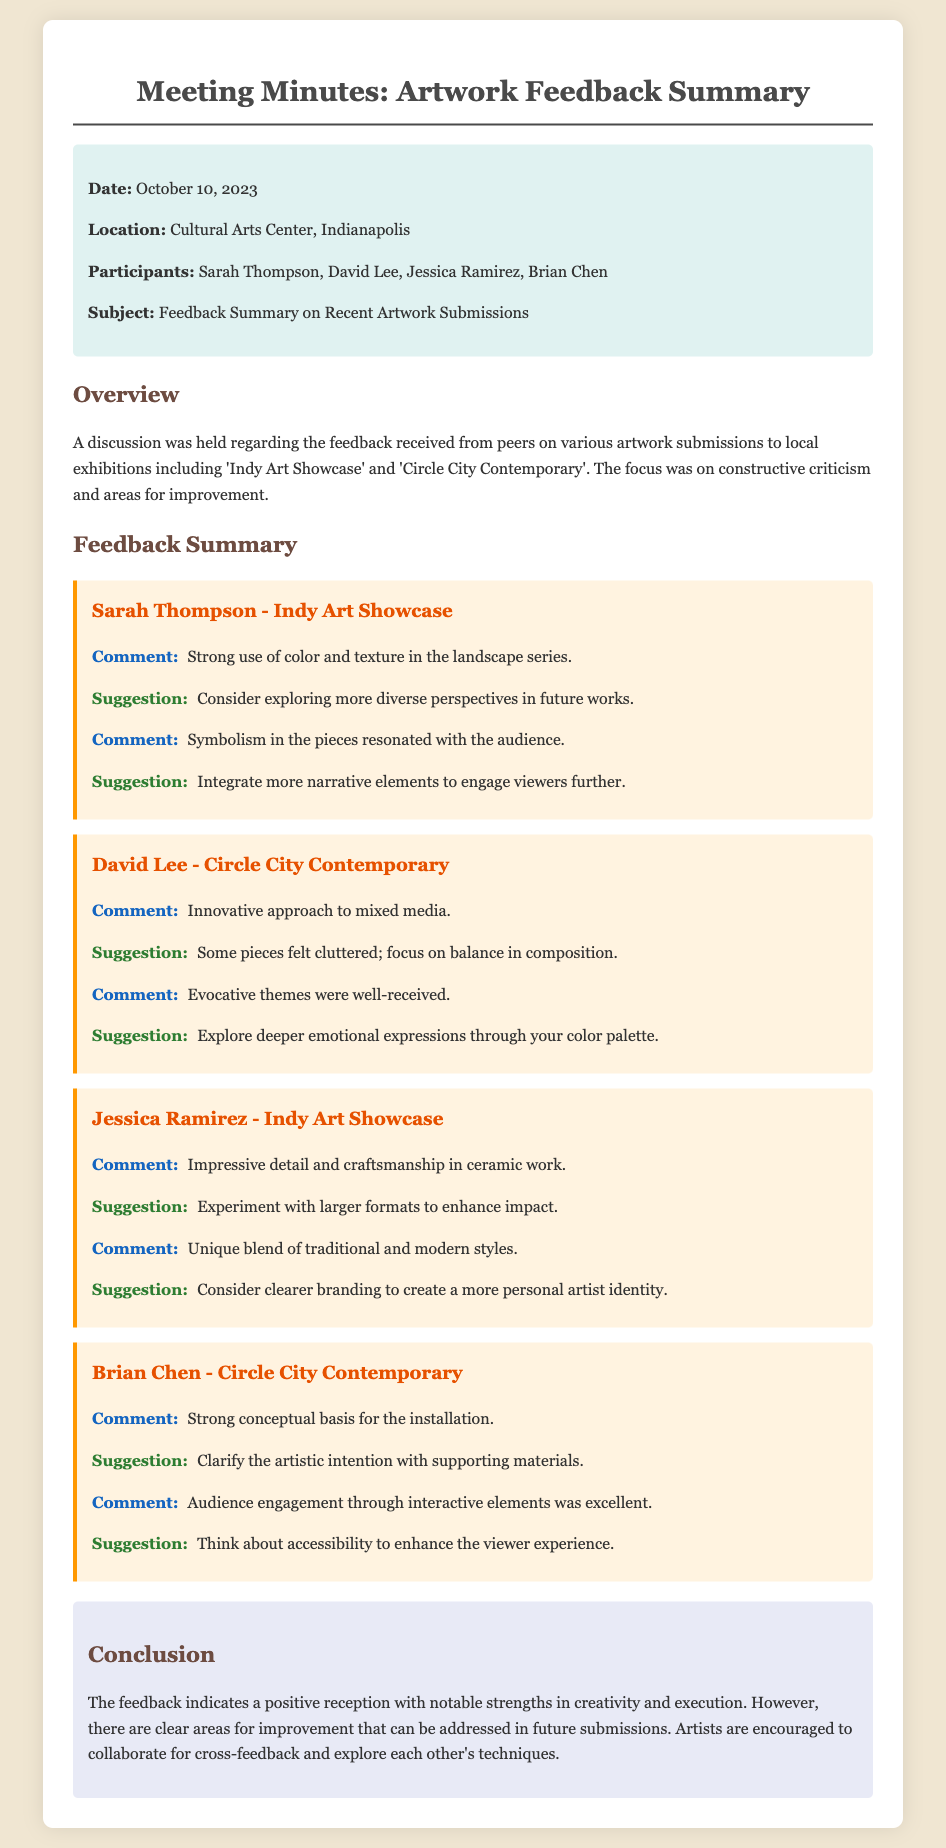what is the date of the meeting? The meeting date is stated clearly in the document under the info section.
Answer: October 10, 2023 who provided feedback on the Indy Art Showcase? The feedback section mentions individual contributors, including Sarah Thompson and Jessica Ramirez.
Answer: Sarah Thompson, Jessica Ramirez what was one of Brian Chen's strengths in his artwork? The comments regarding Brian Chen highlight specific strengths found in his installation.
Answer: Strong conceptual basis what suggestion was given to David Lee regarding composition? The document outlines specific suggestions for each artist's work, including David Lee's.
Answer: Focus on balance in composition how did Jessica Ramirez blend traditional and modern styles? The document describes Jessica Ramirez's work and comments on its uniqueness.
Answer: Unique blend of traditional and modern styles which location hosted the meeting? The location is mentioned at the beginning of the document.
Answer: Cultural Arts Center, Indianapolis what was a suggestion given to Sarah Thompson? Suggestions provided in the document are listed after the comments for each artist.
Answer: Consider exploring more diverse perspectives what aspect of Brian Chen's installation was praised? Feedback includes comments on strengths such as audience engagement in Brian Chen's work.
Answer: Audience engagement through interactive elements what is the overarching conclusion of the feedback session? The conclusion summarizes the general sentiments expressed about the artwork submitted.
Answer: Positive reception with notable strengths in creativity and execution 